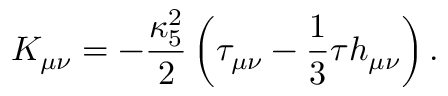<formula> <loc_0><loc_0><loc_500><loc_500>K _ { \mu \nu } = - \frac { \kappa _ { 5 } ^ { 2 } } { 2 } \left ( \tau _ { \mu \nu } - \frac { 1 } { 3 } \tau h _ { \mu \nu } \right ) .</formula> 